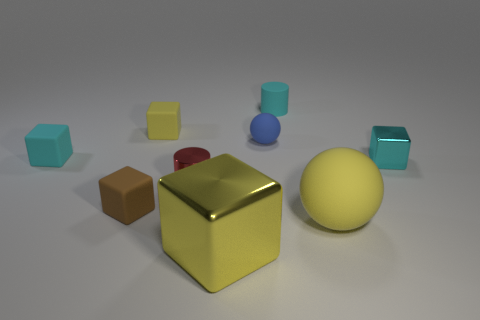Subtract all big metal blocks. How many blocks are left? 4 Subtract all cyan cylinders. How many yellow blocks are left? 2 Subtract 1 blocks. How many blocks are left? 4 Subtract all brown blocks. How many blocks are left? 4 Subtract all balls. Subtract all rubber cubes. How many objects are left? 4 Add 6 small cyan cylinders. How many small cyan cylinders are left? 7 Add 9 big purple shiny cubes. How many big purple shiny cubes exist? 9 Subtract 0 green spheres. How many objects are left? 9 Subtract all cubes. How many objects are left? 4 Subtract all green cubes. Subtract all red spheres. How many cubes are left? 5 